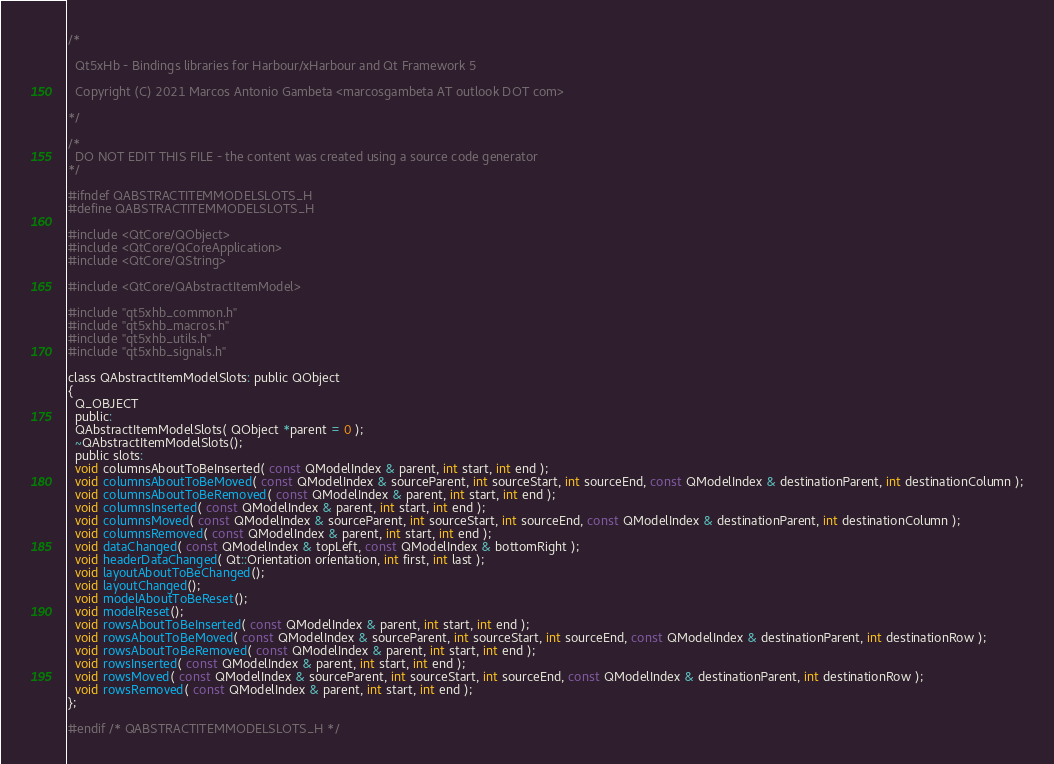<code> <loc_0><loc_0><loc_500><loc_500><_C_>/*

  Qt5xHb - Bindings libraries for Harbour/xHarbour and Qt Framework 5

  Copyright (C) 2021 Marcos Antonio Gambeta <marcosgambeta AT outlook DOT com>

*/

/*
  DO NOT EDIT THIS FILE - the content was created using a source code generator
*/

#ifndef QABSTRACTITEMMODELSLOTS_H
#define QABSTRACTITEMMODELSLOTS_H

#include <QtCore/QObject>
#include <QtCore/QCoreApplication>
#include <QtCore/QString>

#include <QtCore/QAbstractItemModel>

#include "qt5xhb_common.h"
#include "qt5xhb_macros.h"
#include "qt5xhb_utils.h"
#include "qt5xhb_signals.h"

class QAbstractItemModelSlots: public QObject
{
  Q_OBJECT
  public:
  QAbstractItemModelSlots( QObject *parent = 0 );
  ~QAbstractItemModelSlots();
  public slots:
  void columnsAboutToBeInserted( const QModelIndex & parent, int start, int end );
  void columnsAboutToBeMoved( const QModelIndex & sourceParent, int sourceStart, int sourceEnd, const QModelIndex & destinationParent, int destinationColumn );
  void columnsAboutToBeRemoved( const QModelIndex & parent, int start, int end );
  void columnsInserted( const QModelIndex & parent, int start, int end );
  void columnsMoved( const QModelIndex & sourceParent, int sourceStart, int sourceEnd, const QModelIndex & destinationParent, int destinationColumn );
  void columnsRemoved( const QModelIndex & parent, int start, int end );
  void dataChanged( const QModelIndex & topLeft, const QModelIndex & bottomRight );
  void headerDataChanged( Qt::Orientation orientation, int first, int last );
  void layoutAboutToBeChanged();
  void layoutChanged();
  void modelAboutToBeReset();
  void modelReset();
  void rowsAboutToBeInserted( const QModelIndex & parent, int start, int end );
  void rowsAboutToBeMoved( const QModelIndex & sourceParent, int sourceStart, int sourceEnd, const QModelIndex & destinationParent, int destinationRow );
  void rowsAboutToBeRemoved( const QModelIndex & parent, int start, int end );
  void rowsInserted( const QModelIndex & parent, int start, int end );
  void rowsMoved( const QModelIndex & sourceParent, int sourceStart, int sourceEnd, const QModelIndex & destinationParent, int destinationRow );
  void rowsRemoved( const QModelIndex & parent, int start, int end );
};

#endif /* QABSTRACTITEMMODELSLOTS_H */
</code> 